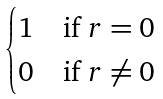Convert formula to latex. <formula><loc_0><loc_0><loc_500><loc_500>\begin{cases} 1 & \text {if $r=0$} \\ 0 & \text {if $r \ne 0$} \end{cases}</formula> 